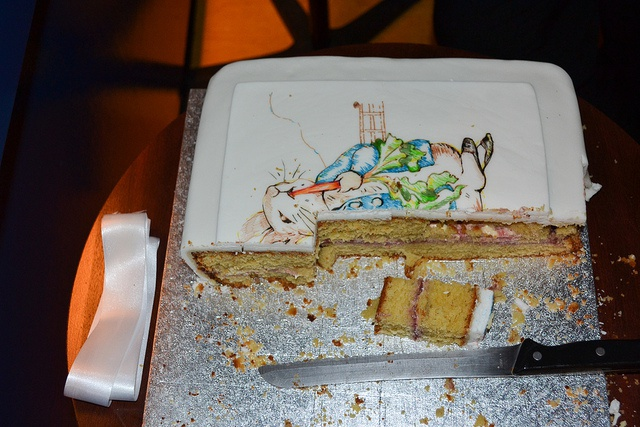Describe the objects in this image and their specific colors. I can see dining table in darkgray, black, gray, and tan tones, cake in black, olive, and gray tones, knife in black, darkgray, and gray tones, cake in black, olive, and darkgray tones, and carrot in black, red, brown, and salmon tones in this image. 